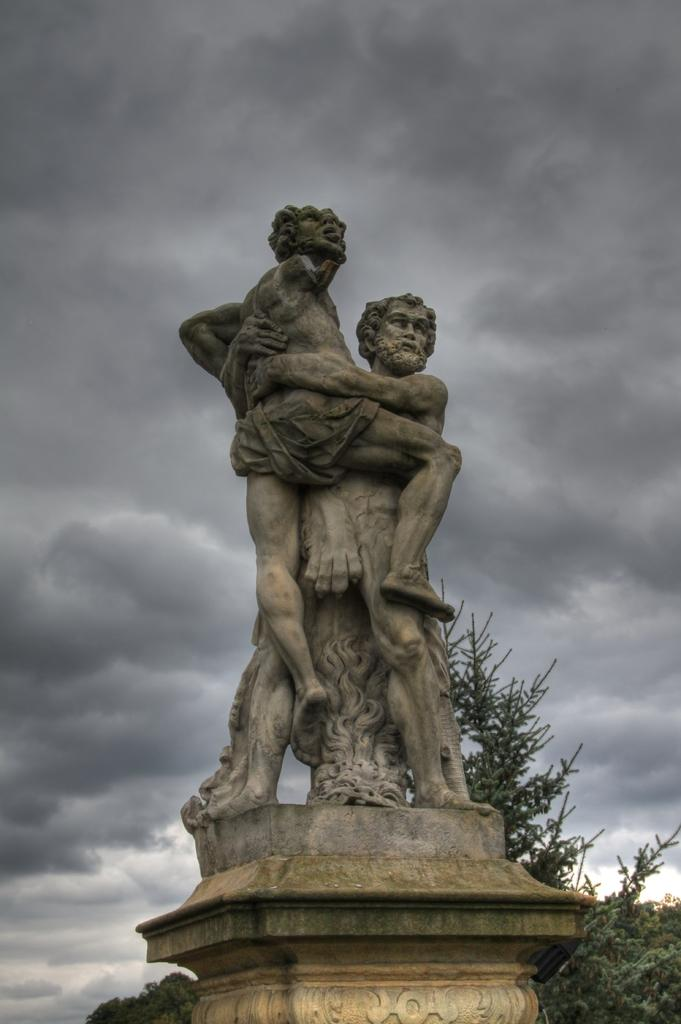What is the main subject in the image? There is a statue in the image. What other elements can be seen in the image? There are trees in the image. What can be seen in the background of the image? The sky is visible in the background of the image. What is the condition of the sky in the image? Clouds are present in the sky. Where is the crib located in the image? There is no crib present in the image. What type of market can be seen in the background of the image? There is no market present in the image; it features a statue, trees, and a sky with clouds. 